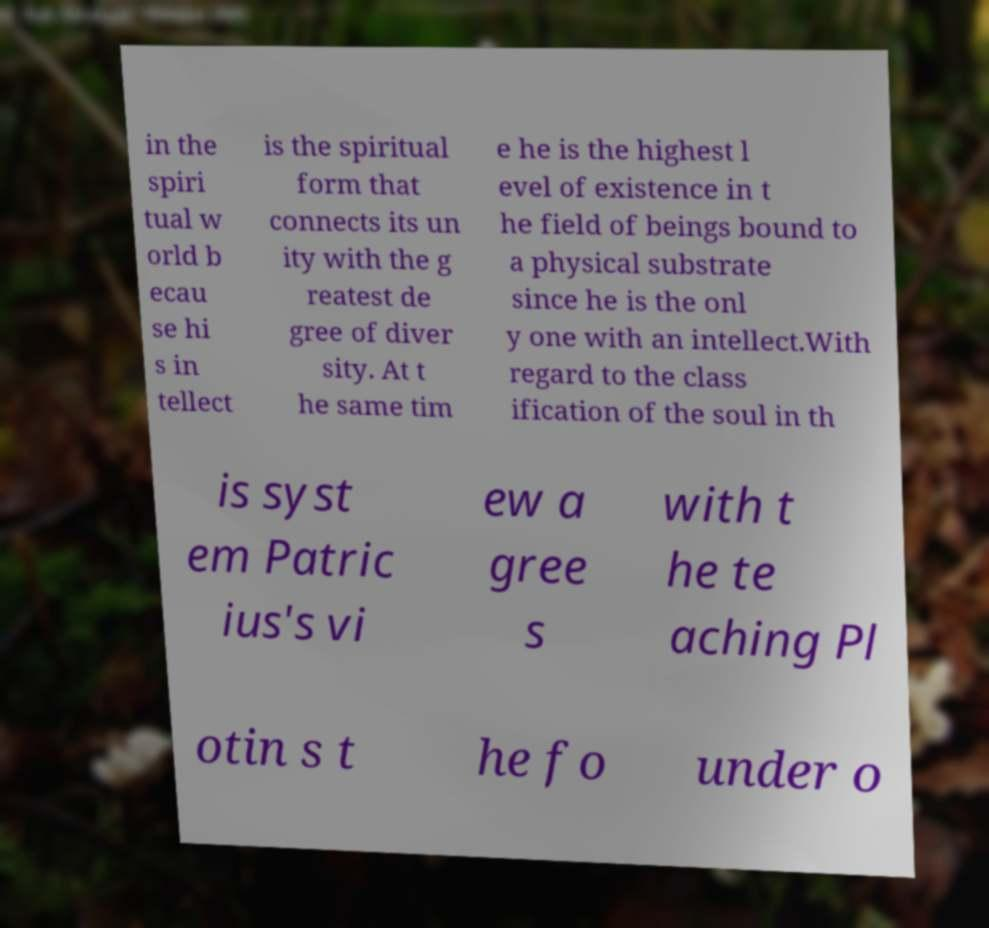I need the written content from this picture converted into text. Can you do that? in the spiri tual w orld b ecau se hi s in tellect is the spiritual form that connects its un ity with the g reatest de gree of diver sity. At t he same tim e he is the highest l evel of existence in t he field of beings bound to a physical substrate since he is the onl y one with an intellect.With regard to the class ification of the soul in th is syst em Patric ius's vi ew a gree s with t he te aching Pl otin s t he fo under o 